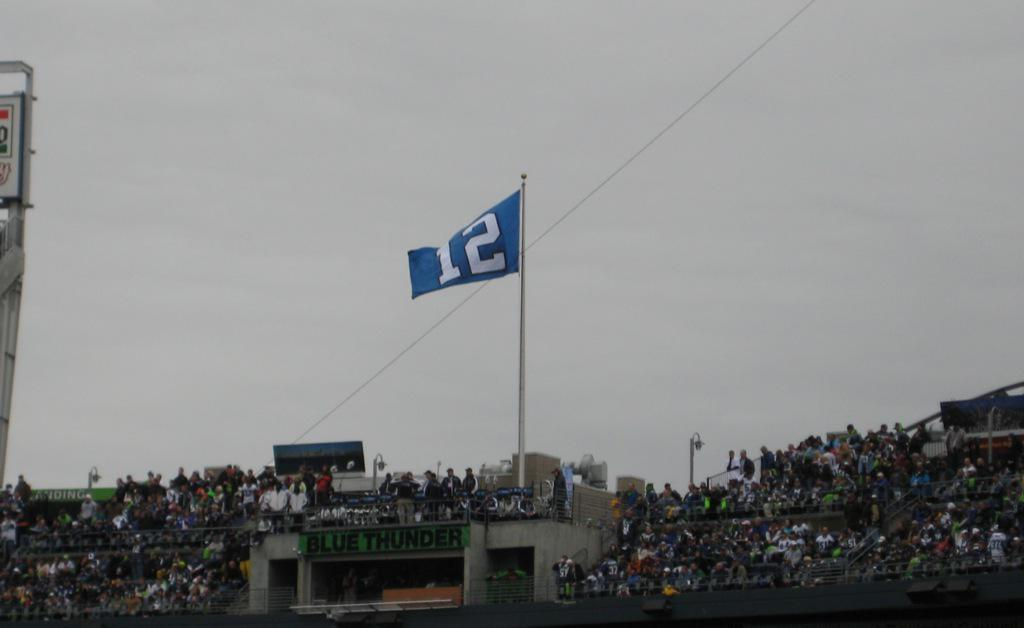<image>
Describe the image concisely. a blue flag with the number 12 on it 